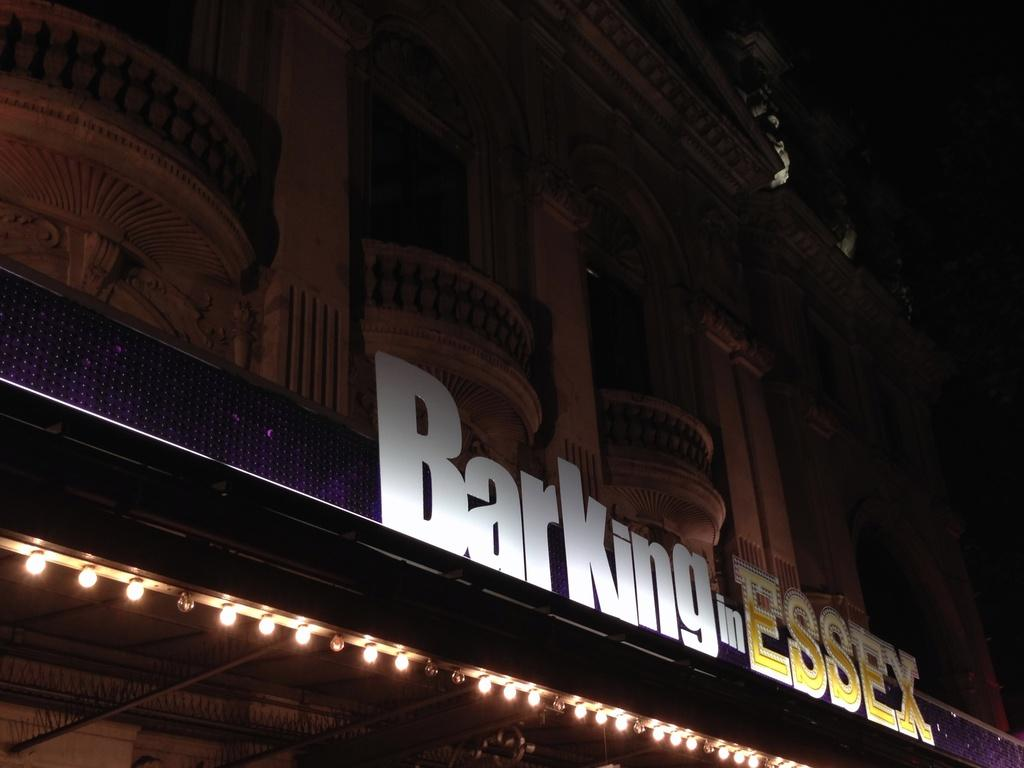What type of structure is visible in the image? There is a building in the image. Can you describe any additional features at the bottom of the image? There are lights at the bottom of the image. What type of seed is planted at the top of the building in the image? There is no seed or planting mentioned in the image; it only features a building and lights at the bottom. 